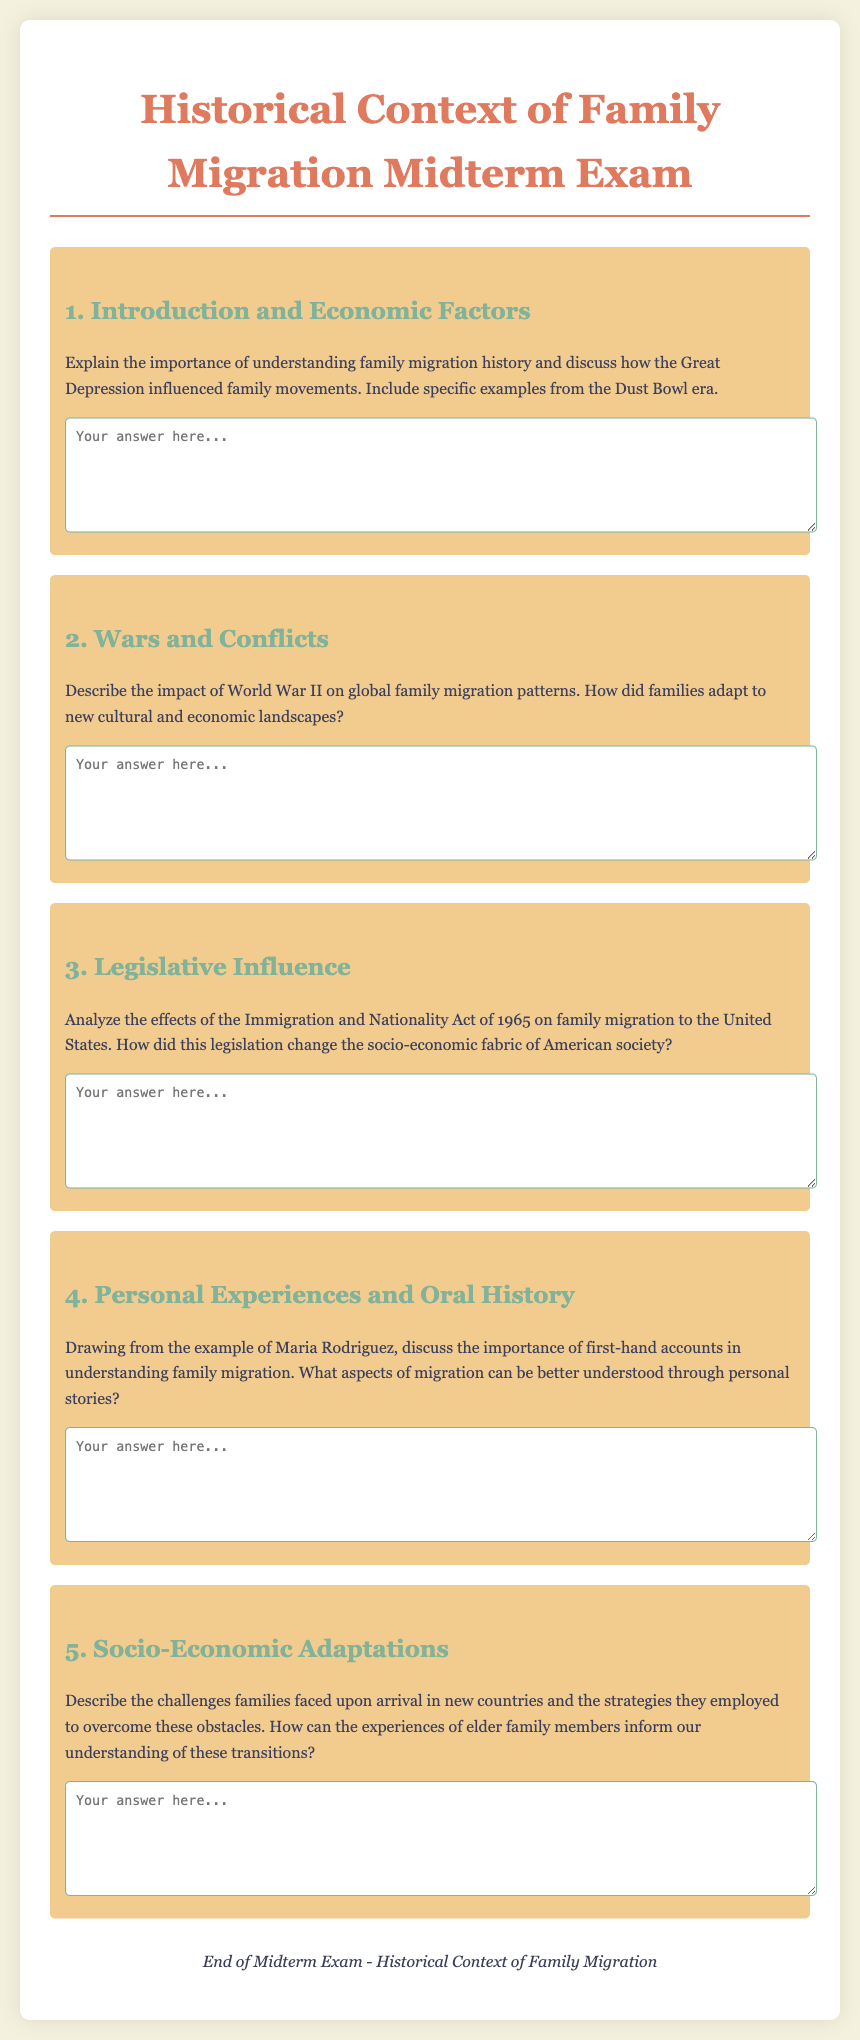What is the title of the midterm exam? The title of the midterm exam is clearly stated at the top of the document.
Answer: Historical Context of Family Migration Midterm Exam How many main questions are included in the document? The document contains a specific number of questions that are outlined sequentially.
Answer: 5 Which historical event is mentioned as influencing family movements in the first question? The first question references a significant event that impacted population movements during a specific period.
Answer: Great Depression What year did the Immigration and Nationality Act take place? The effects of the Immigration and Nationality Act are discussed in question three, signifying a critical year.
Answer: 1965 Who is given as an example in the fourth question regarding family migration accounts? The example mentioned in the fourth question illustrates the importance of first-hand narratives in understanding migration.
Answer: Maria Rodriguez What color is used for the header of each question? The header of each question is distinguished by a specific color that highlights the section in the document.
Answer: #81b29a 